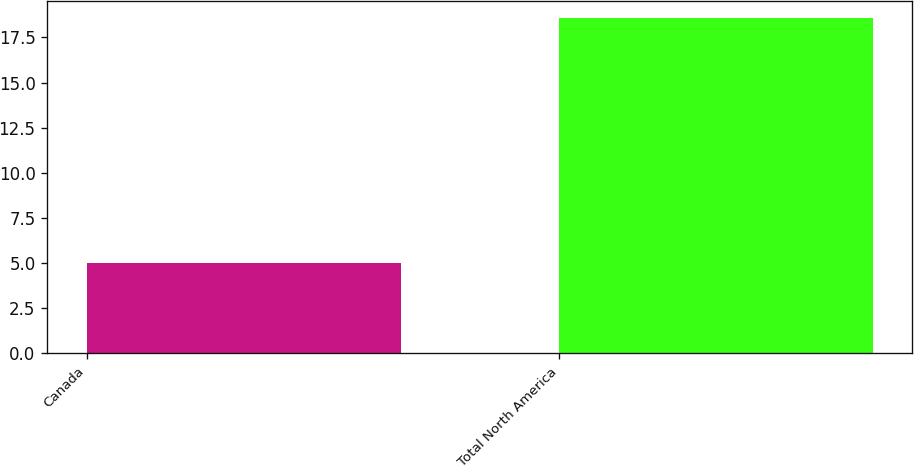<chart> <loc_0><loc_0><loc_500><loc_500><bar_chart><fcel>Canada<fcel>Total North America<nl><fcel>5<fcel>18.6<nl></chart> 